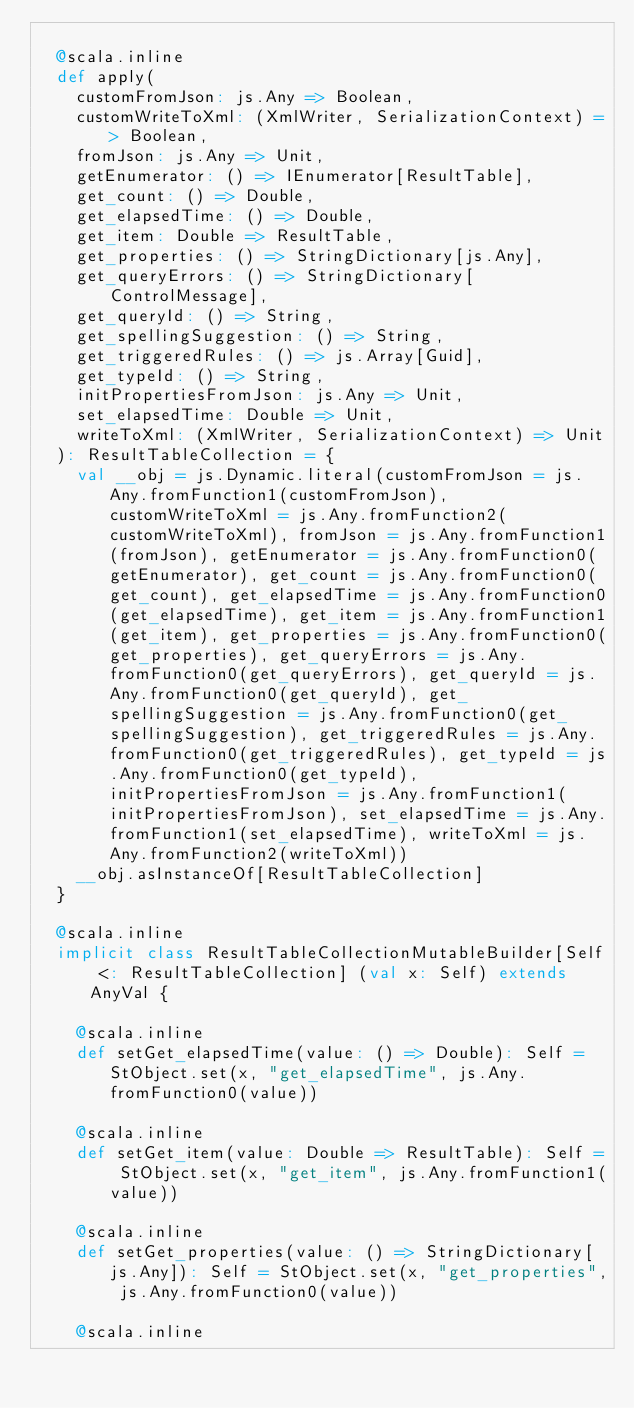Convert code to text. <code><loc_0><loc_0><loc_500><loc_500><_Scala_>  
  @scala.inline
  def apply(
    customFromJson: js.Any => Boolean,
    customWriteToXml: (XmlWriter, SerializationContext) => Boolean,
    fromJson: js.Any => Unit,
    getEnumerator: () => IEnumerator[ResultTable],
    get_count: () => Double,
    get_elapsedTime: () => Double,
    get_item: Double => ResultTable,
    get_properties: () => StringDictionary[js.Any],
    get_queryErrors: () => StringDictionary[ControlMessage],
    get_queryId: () => String,
    get_spellingSuggestion: () => String,
    get_triggeredRules: () => js.Array[Guid],
    get_typeId: () => String,
    initPropertiesFromJson: js.Any => Unit,
    set_elapsedTime: Double => Unit,
    writeToXml: (XmlWriter, SerializationContext) => Unit
  ): ResultTableCollection = {
    val __obj = js.Dynamic.literal(customFromJson = js.Any.fromFunction1(customFromJson), customWriteToXml = js.Any.fromFunction2(customWriteToXml), fromJson = js.Any.fromFunction1(fromJson), getEnumerator = js.Any.fromFunction0(getEnumerator), get_count = js.Any.fromFunction0(get_count), get_elapsedTime = js.Any.fromFunction0(get_elapsedTime), get_item = js.Any.fromFunction1(get_item), get_properties = js.Any.fromFunction0(get_properties), get_queryErrors = js.Any.fromFunction0(get_queryErrors), get_queryId = js.Any.fromFunction0(get_queryId), get_spellingSuggestion = js.Any.fromFunction0(get_spellingSuggestion), get_triggeredRules = js.Any.fromFunction0(get_triggeredRules), get_typeId = js.Any.fromFunction0(get_typeId), initPropertiesFromJson = js.Any.fromFunction1(initPropertiesFromJson), set_elapsedTime = js.Any.fromFunction1(set_elapsedTime), writeToXml = js.Any.fromFunction2(writeToXml))
    __obj.asInstanceOf[ResultTableCollection]
  }
  
  @scala.inline
  implicit class ResultTableCollectionMutableBuilder[Self <: ResultTableCollection] (val x: Self) extends AnyVal {
    
    @scala.inline
    def setGet_elapsedTime(value: () => Double): Self = StObject.set(x, "get_elapsedTime", js.Any.fromFunction0(value))
    
    @scala.inline
    def setGet_item(value: Double => ResultTable): Self = StObject.set(x, "get_item", js.Any.fromFunction1(value))
    
    @scala.inline
    def setGet_properties(value: () => StringDictionary[js.Any]): Self = StObject.set(x, "get_properties", js.Any.fromFunction0(value))
    
    @scala.inline</code> 